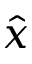Convert formula to latex. <formula><loc_0><loc_0><loc_500><loc_500>\hat { x }</formula> 